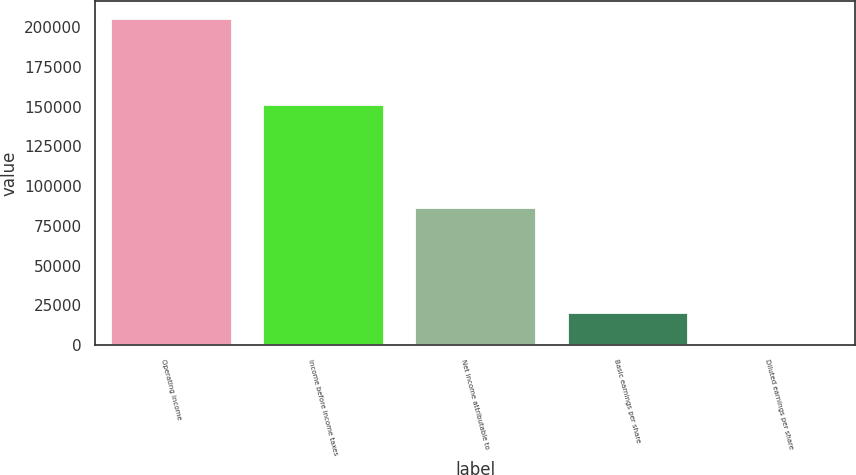Convert chart to OTSL. <chart><loc_0><loc_0><loc_500><loc_500><bar_chart><fcel>Operating income<fcel>Income before income taxes<fcel>Net income attributable to<fcel>Basic earnings per share<fcel>Diluted earnings per share<nl><fcel>205781<fcel>151578<fcel>86934<fcel>20578.8<fcel>0.8<nl></chart> 